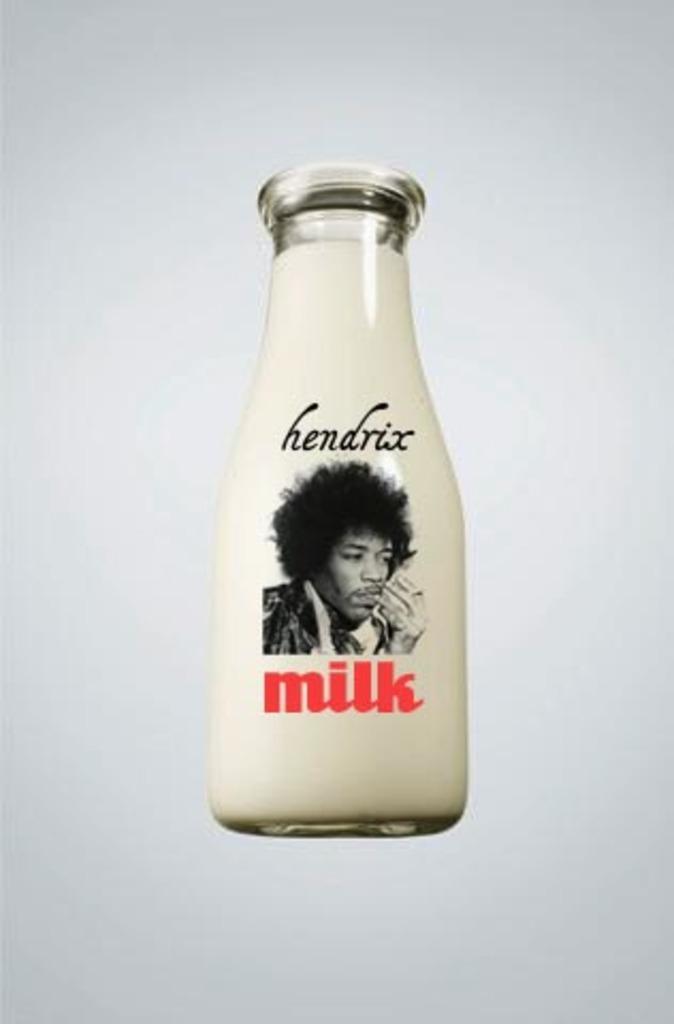Can you describe this image briefly? In the picture I can see the milk bottle on which I can see the image of a person and some text. The background of the image is in white color. 